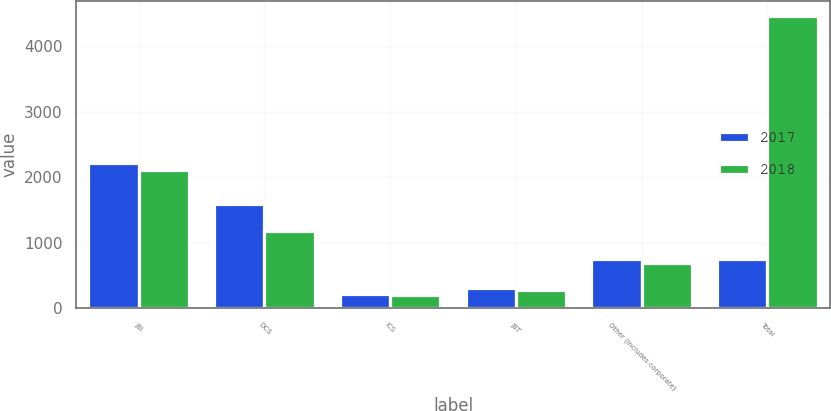<chart> <loc_0><loc_0><loc_500><loc_500><stacked_bar_chart><ecel><fcel>JBI<fcel>DCS<fcel>ICS<fcel>JBT<fcel>Other (includes corporate)<fcel>Total<nl><fcel>2017<fcel>2221<fcel>1595<fcel>212<fcel>307<fcel>757<fcel>757<nl><fcel>2018<fcel>2108<fcel>1182<fcel>204<fcel>283<fcel>688<fcel>4465<nl></chart> 